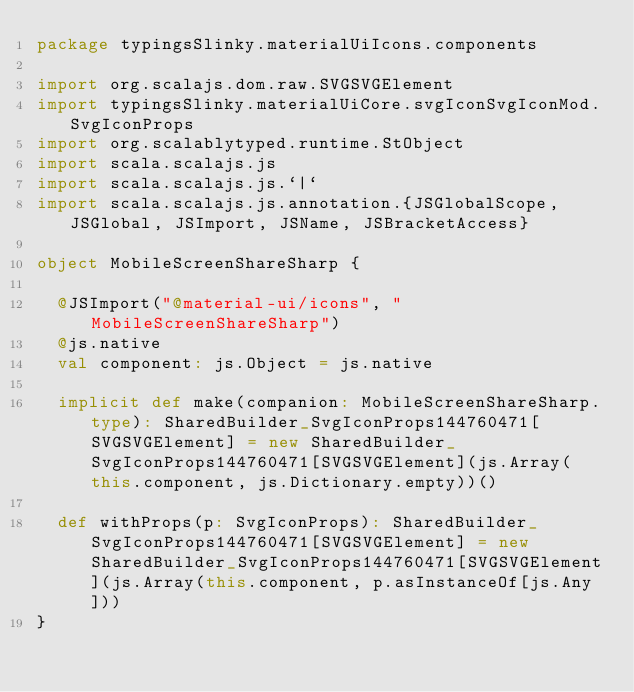Convert code to text. <code><loc_0><loc_0><loc_500><loc_500><_Scala_>package typingsSlinky.materialUiIcons.components

import org.scalajs.dom.raw.SVGSVGElement
import typingsSlinky.materialUiCore.svgIconSvgIconMod.SvgIconProps
import org.scalablytyped.runtime.StObject
import scala.scalajs.js
import scala.scalajs.js.`|`
import scala.scalajs.js.annotation.{JSGlobalScope, JSGlobal, JSImport, JSName, JSBracketAccess}

object MobileScreenShareSharp {
  
  @JSImport("@material-ui/icons", "MobileScreenShareSharp")
  @js.native
  val component: js.Object = js.native
  
  implicit def make(companion: MobileScreenShareSharp.type): SharedBuilder_SvgIconProps144760471[SVGSVGElement] = new SharedBuilder_SvgIconProps144760471[SVGSVGElement](js.Array(this.component, js.Dictionary.empty))()
  
  def withProps(p: SvgIconProps): SharedBuilder_SvgIconProps144760471[SVGSVGElement] = new SharedBuilder_SvgIconProps144760471[SVGSVGElement](js.Array(this.component, p.asInstanceOf[js.Any]))
}
</code> 